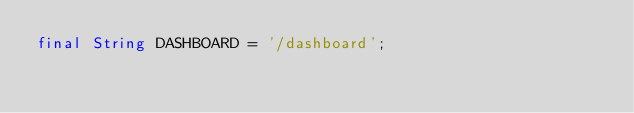<code> <loc_0><loc_0><loc_500><loc_500><_Dart_>final String DASHBOARD = '/dashboard';
</code> 